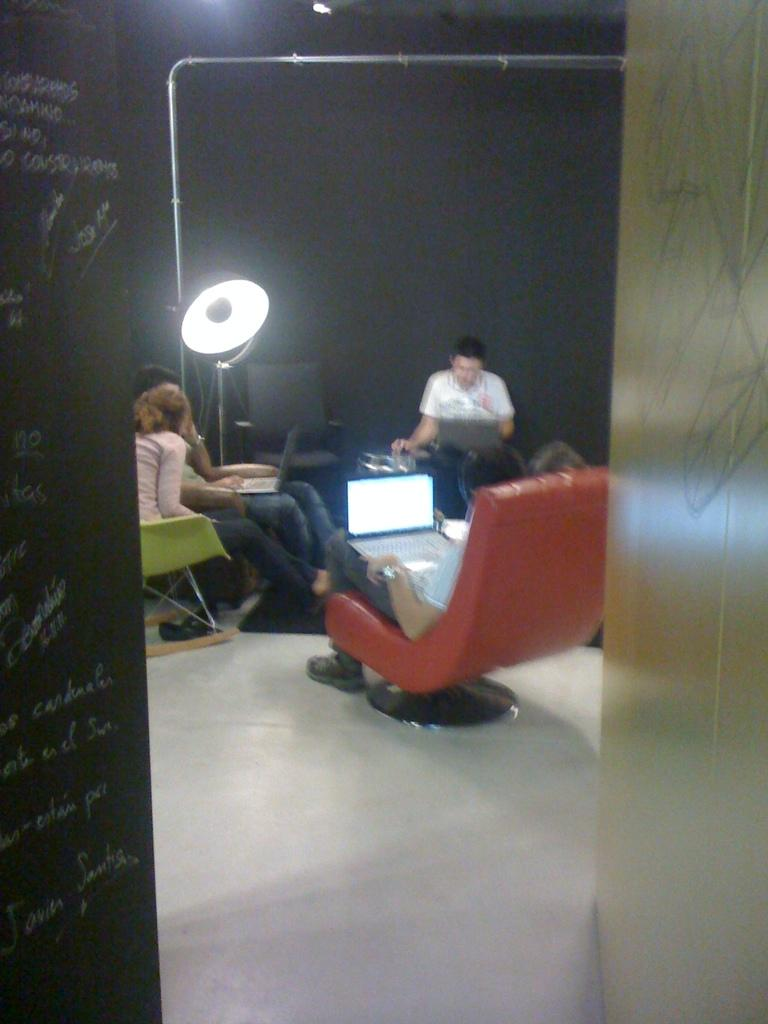Who or what can be seen in the image in the image? There are people in the image. What are the people doing in the image? The people are sitting on chairs. What objects are the people holding or using in the image? The people have laptops in their laps. How many kittens are sitting on the roof in the image? There are no kittens or roof present in the image. 